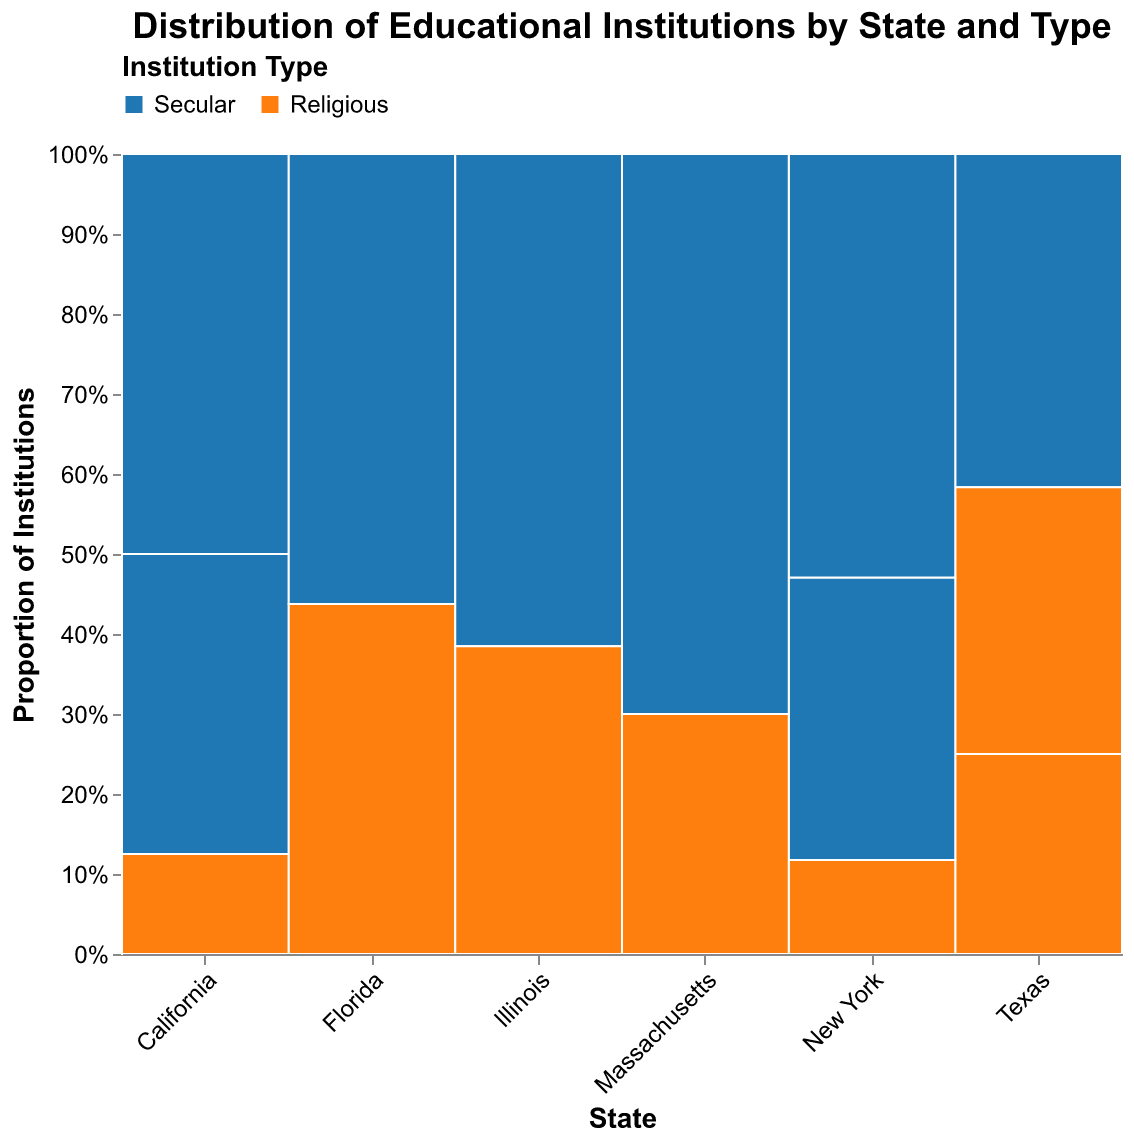What is the color used to represent secular institutions in the figure? The figure uses a legend at the top to indicate which colors represent the different institution types. According to the legend, secular institutions are represented by the color blue.
Answer: Blue What state has the highest number of high-funded secular institutions? To determine this, we look at the height of the blue bars in the "High" funding level category across states. California has the tallest blue bar in this category, indicating the highest number of high-funded secular institutions.
Answer: California How many secular institutions are there in Massachusetts? Adding the heights of the blue bars for Massachusetts across all funding levels (high, medium, and low), you get 70 + 0 + 0 = 70.
Answer: 70 Which state has the lowest proportion of religious institutions? To find this, we look for the state where the orange bars (representing religious institutions) take up the smallest proportion of the entire bar height. Massachusetts has the smallest proportion of religious institutions relative to the state’s total number of institutions.
Answer: Massachusetts Compare the funding levels of religious institutions in Texas and Florida. Which state has a higher number of medium-funded religious institutions? In Texas, the orange bar corresponding to medium funding is taller than that in Florida. Thus, Texas has a higher number of medium-funded religious institutions.
Answer: Texas What is the total number of institutions in Illinois? Sum the heights of all bars (both secular and religious) for Illinois across all funding levels. This gives us 80 (secular high) + 50 (religious medium) = 130.
Answer: 130 Which state has the highest proportion of institutions at the medium funding level? For this, look at the overall bar height for each state and identify which state has the tallest combined (blue and orange) bar in the medium funding level. California has the tallest combined bar in this category.
Answer: California How does the number of low-funded religious institutions in New York compare to Illinois? Compare the orange bars at the low funding level between New York and Illinois. New York has 40 low-funded religious institutions, while Illinois has none in this category (since no relevant bar is shown).
Answer: New York What is the total number of high-funded secular institutions across all states? Add the heights of all the blue bars at the high funding level for each state. This results in 150 (California) + 120 (New York) + 80 (Illinois) + 70 (Massachusetts) = 420.
Answer: 420 